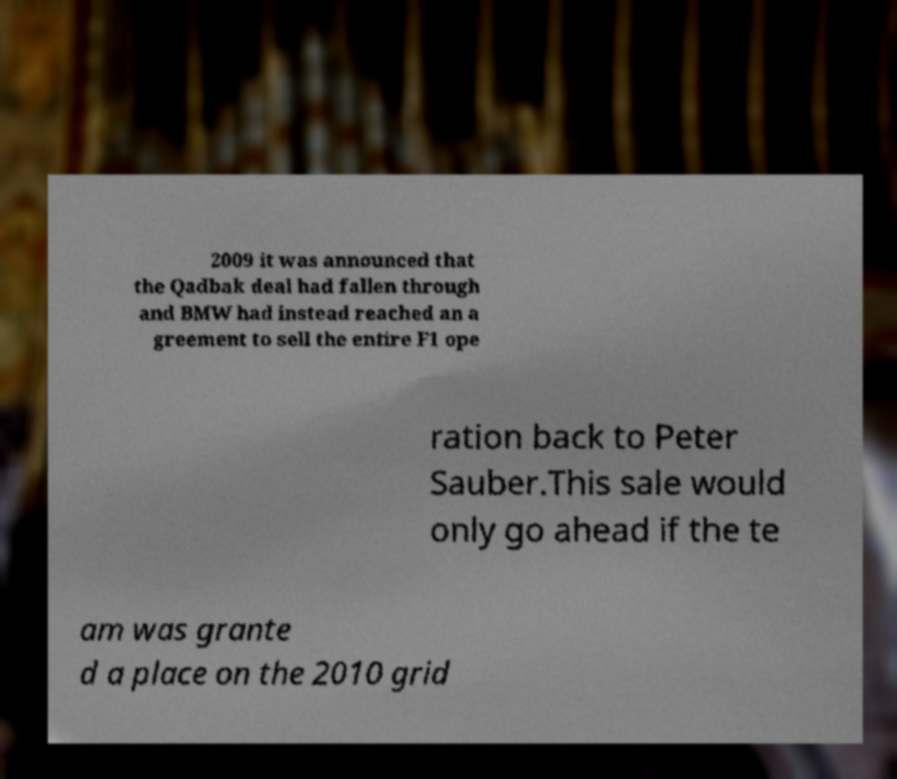Can you accurately transcribe the text from the provided image for me? 2009 it was announced that the Qadbak deal had fallen through and BMW had instead reached an a greement to sell the entire F1 ope ration back to Peter Sauber.This sale would only go ahead if the te am was grante d a place on the 2010 grid 